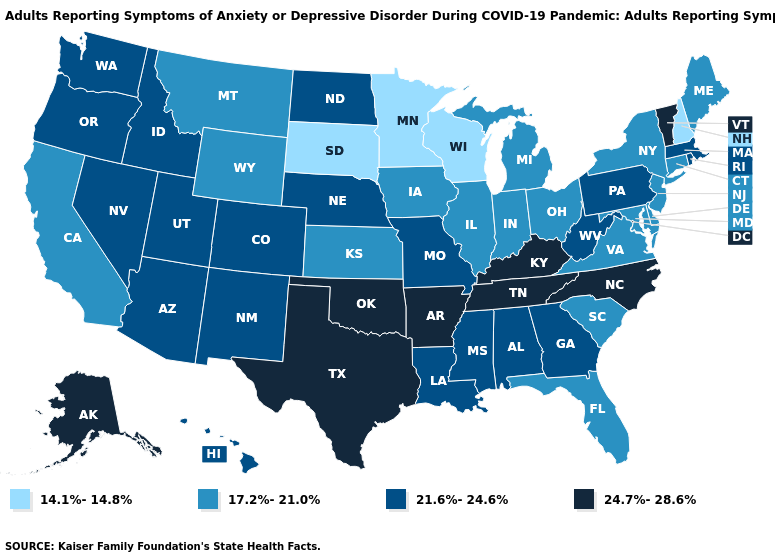Name the states that have a value in the range 21.6%-24.6%?
Answer briefly. Alabama, Arizona, Colorado, Georgia, Hawaii, Idaho, Louisiana, Massachusetts, Mississippi, Missouri, Nebraska, Nevada, New Mexico, North Dakota, Oregon, Pennsylvania, Rhode Island, Utah, Washington, West Virginia. What is the value of Minnesota?
Be succinct. 14.1%-14.8%. Does Colorado have the highest value in the USA?
Give a very brief answer. No. Does the first symbol in the legend represent the smallest category?
Write a very short answer. Yes. What is the highest value in the West ?
Concise answer only. 24.7%-28.6%. Name the states that have a value in the range 14.1%-14.8%?
Be succinct. Minnesota, New Hampshire, South Dakota, Wisconsin. Does Virginia have a higher value than Connecticut?
Concise answer only. No. Name the states that have a value in the range 24.7%-28.6%?
Keep it brief. Alaska, Arkansas, Kentucky, North Carolina, Oklahoma, Tennessee, Texas, Vermont. Among the states that border Illinois , does Wisconsin have the highest value?
Short answer required. No. How many symbols are there in the legend?
Write a very short answer. 4. Is the legend a continuous bar?
Answer briefly. No. What is the highest value in the USA?
Keep it brief. 24.7%-28.6%. Name the states that have a value in the range 14.1%-14.8%?
Concise answer only. Minnesota, New Hampshire, South Dakota, Wisconsin. What is the highest value in states that border New Jersey?
Short answer required. 21.6%-24.6%. Name the states that have a value in the range 17.2%-21.0%?
Short answer required. California, Connecticut, Delaware, Florida, Illinois, Indiana, Iowa, Kansas, Maine, Maryland, Michigan, Montana, New Jersey, New York, Ohio, South Carolina, Virginia, Wyoming. 